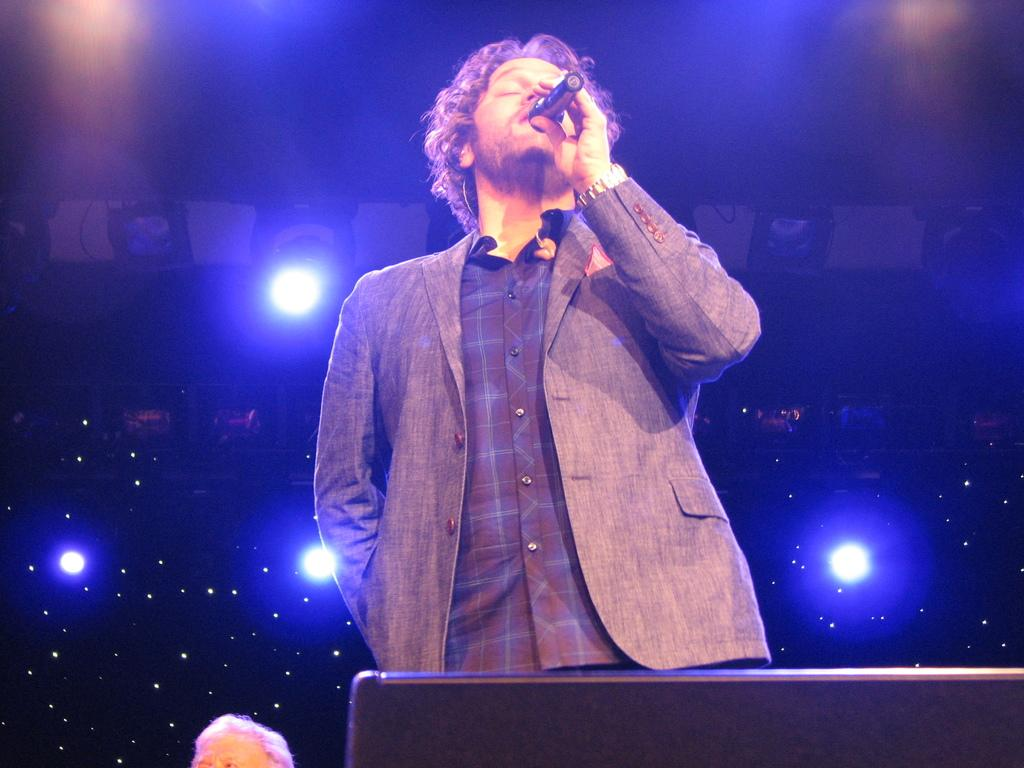Who is the main subject in the image? There is a man in the image. What is the man doing in the image? The man is singing. What object is the man holding in the image? The man is holding a microphone. What is the man wearing in the image? The man is wearing a suit. What can be seen in the background of the image? There are lights in the background of the image. What type of kite is the man flying during the rainstorm in the image? There is no kite or rainstorm present in the image; it features a man singing while holding a microphone. In which month is the man singing in the image? The month is not mentioned or visible in the image, so it cannot be determined. 